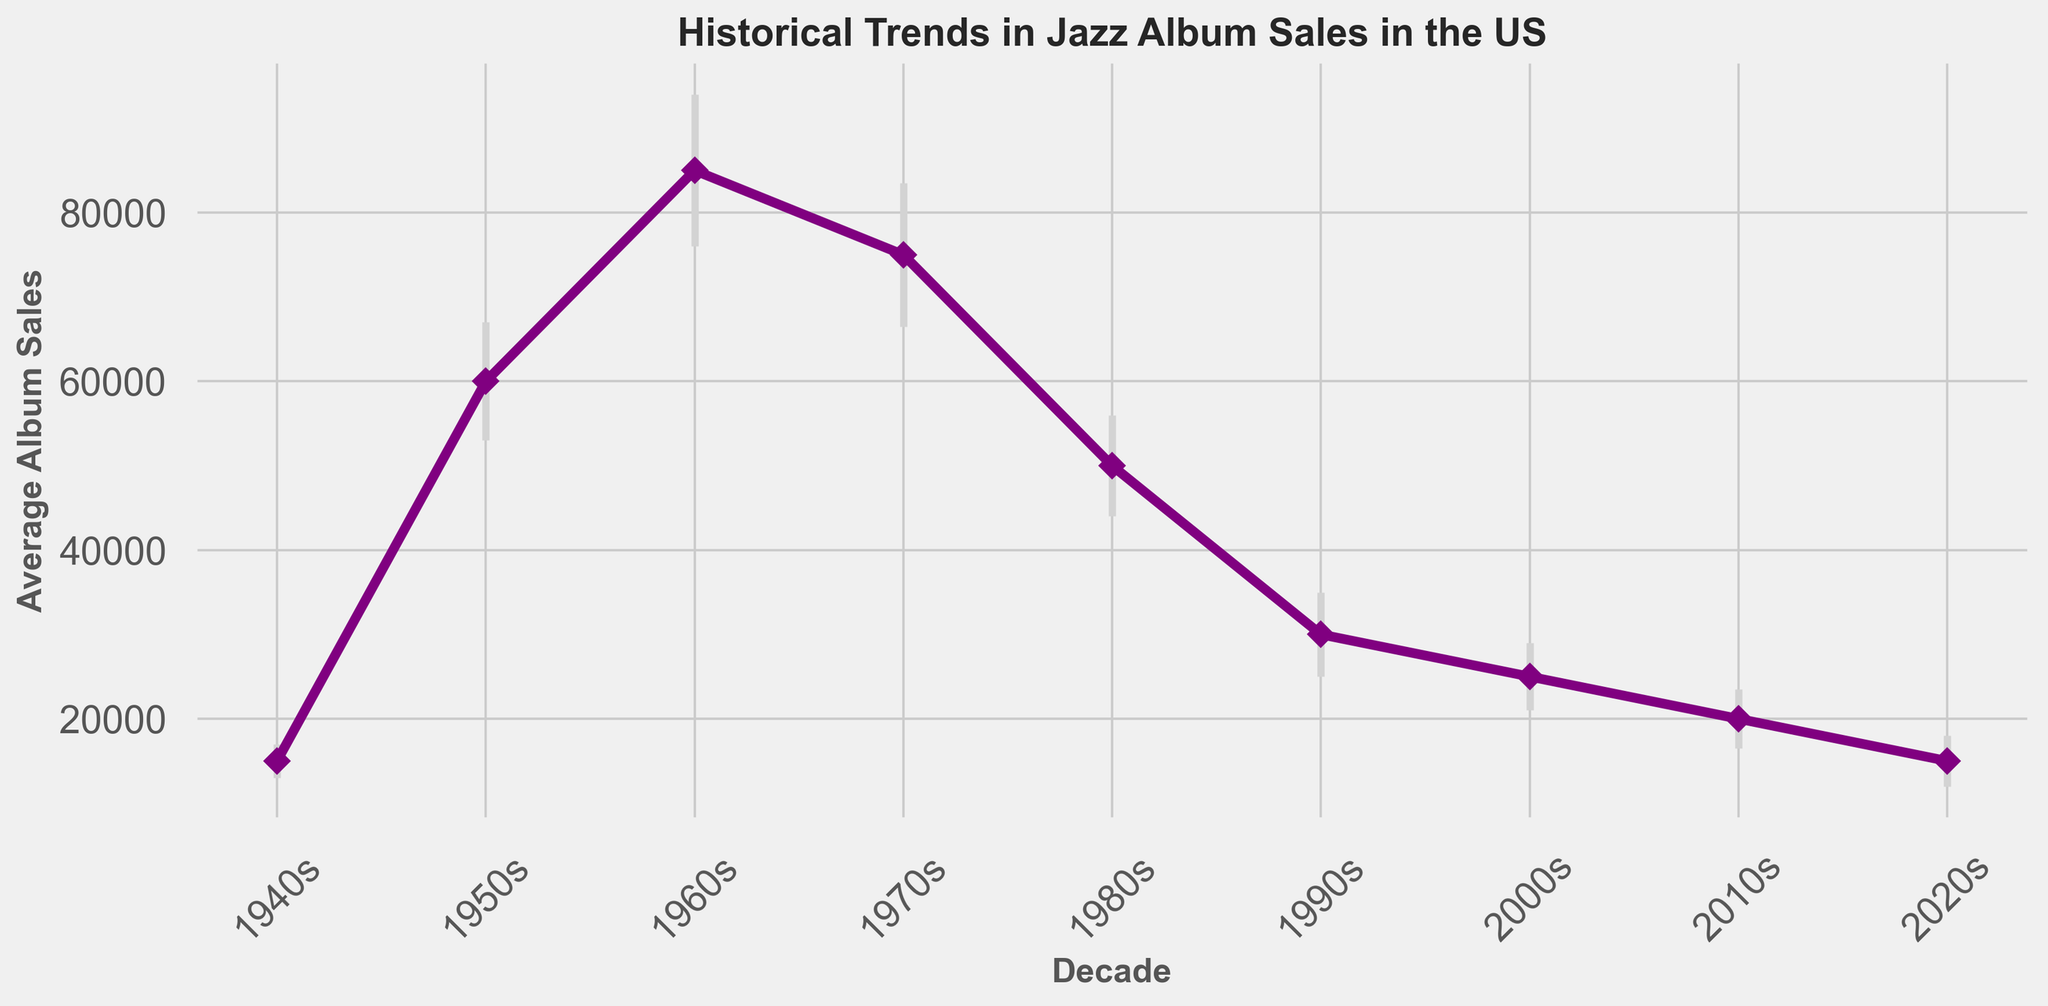What's the standard deviation of album sales in the 1950s? The chart shows that the standard deviation for the 1950s is indicated as a vertical error bar at each decade marker. For the 1950s, the standard deviation is labeled directly in the data provided.
Answer: 7000 What decade had the highest average album sales? By observing the heights of the points on the graph, the decade with the highest point corresponds to the 1960s.
Answer: 1960s How does the average album sales in the 1980s compare to the 1990s? Comparing the points directly, the average album sales in the 1980s are higher than in the 1990s. The 1980s have a value of 50000, while the 1990s have a value of 30000.
Answer: The 1980s have higher sales What is the difference in average album sales between the 1960s and the 2020s? The 1960s have average album sales of 85000, while the 2020s have 15000. Subtracting these, 85000 - 15000, gives the difference.
Answer: 70000 What decade had the largest standard deviation in album sales? Observing the lengths of the error bars, the 1960s have the largest vertical error bar which indicates the largest standard deviation.
Answer: 1960s Which decade saw a decrease in average album sales compared to the previous decade? To find this, look for points where the value drops from one decade to the next. There are drops from the 1960s to the 1970s, the 1970s to the 1980s, the 1980s to the 1990s, the 1990s to the 2000s, the 2000s to the 2010s, and the 2010s to the 2020s.
Answer: 1960s to 1970s, 1970s to 1980s, 1980s to 1990s, 1990s to 2000s, 2000s to 2010s, 2010s to 2020s What is the approximate range of the average album sales in the 1960s, considering the standard deviation? The average is 85000 with a standard deviation of 9000. This means the range is approximately 85000 ± 9000, which gives a range from 76000 to 94000.
Answer: 76000 to 94000 By how much did the average album sales decrease from the 1970s to the 1980s? The 1970s have 75000 in average album sales and the 1980s have 50000. The decrease is 75000 - 50000.
Answer: 25000 What were the average album sales for the 2000s and 2010s combined? Sum the average sales of the 2000s (25000) and the 2010s (20000) to get the combined total. So, 25000 + 20000.
Answer: 45000 Which decade had nearly the same average album sales as the 1940s with lower standard deviation? The 2020s had a similar average album sales (15000) as the 1940s but with a lower standard deviation of 3000 compared to 2000 of the 1940s.
Answer: 2020s 